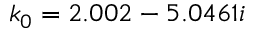<formula> <loc_0><loc_0><loc_500><loc_500>k _ { 0 } = 2 . 0 0 2 - 5 . 0 4 6 1 i</formula> 